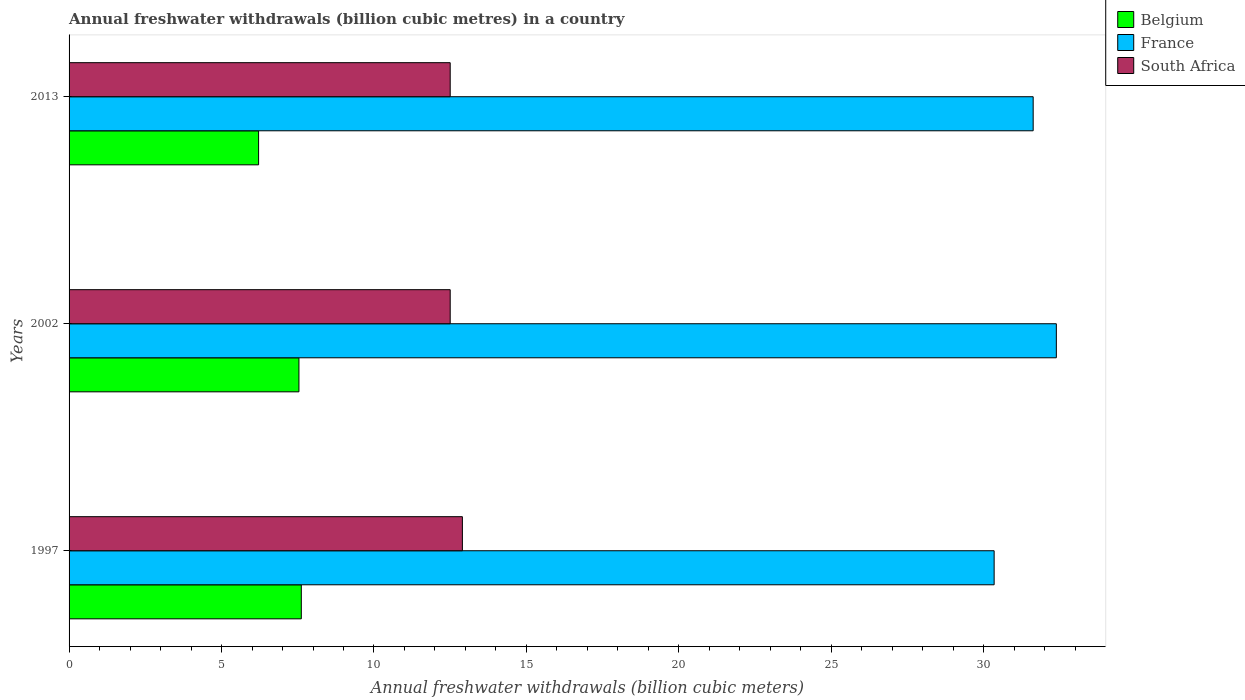How many groups of bars are there?
Provide a succinct answer. 3. Are the number of bars per tick equal to the number of legend labels?
Offer a terse response. Yes. How many bars are there on the 3rd tick from the top?
Offer a very short reply. 3. What is the label of the 1st group of bars from the top?
Provide a succinct answer. 2013. Across all years, what is the maximum annual freshwater withdrawals in France?
Your response must be concise. 32.38. In which year was the annual freshwater withdrawals in South Africa maximum?
Make the answer very short. 1997. In which year was the annual freshwater withdrawals in Belgium minimum?
Make the answer very short. 2013. What is the total annual freshwater withdrawals in France in the graph?
Offer a terse response. 94.34. What is the difference between the annual freshwater withdrawals in South Africa in 1997 and that in 2013?
Offer a terse response. 0.4. What is the difference between the annual freshwater withdrawals in South Africa in 2013 and the annual freshwater withdrawals in Belgium in 1997?
Your answer should be compact. 4.88. What is the average annual freshwater withdrawals in France per year?
Your answer should be very brief. 31.45. In the year 1997, what is the difference between the annual freshwater withdrawals in Belgium and annual freshwater withdrawals in France?
Your answer should be very brief. -22.72. In how many years, is the annual freshwater withdrawals in France greater than 5 billion cubic meters?
Provide a succinct answer. 3. Is the annual freshwater withdrawals in Belgium in 1997 less than that in 2013?
Provide a succinct answer. No. What is the difference between the highest and the second highest annual freshwater withdrawals in South Africa?
Provide a short and direct response. 0.4. What is the difference between the highest and the lowest annual freshwater withdrawals in France?
Give a very brief answer. 2.04. What does the 2nd bar from the bottom in 1997 represents?
Offer a terse response. France. Are the values on the major ticks of X-axis written in scientific E-notation?
Your response must be concise. No. Does the graph contain any zero values?
Make the answer very short. No. Where does the legend appear in the graph?
Your answer should be compact. Top right. How are the legend labels stacked?
Provide a short and direct response. Vertical. What is the title of the graph?
Ensure brevity in your answer.  Annual freshwater withdrawals (billion cubic metres) in a country. Does "St. Kitts and Nevis" appear as one of the legend labels in the graph?
Ensure brevity in your answer.  No. What is the label or title of the X-axis?
Your answer should be compact. Annual freshwater withdrawals (billion cubic meters). What is the Annual freshwater withdrawals (billion cubic meters) in Belgium in 1997?
Provide a succinct answer. 7.62. What is the Annual freshwater withdrawals (billion cubic meters) in France in 1997?
Give a very brief answer. 30.34. What is the Annual freshwater withdrawals (billion cubic meters) in South Africa in 1997?
Make the answer very short. 12.9. What is the Annual freshwater withdrawals (billion cubic meters) in Belgium in 2002?
Your answer should be very brief. 7.54. What is the Annual freshwater withdrawals (billion cubic meters) in France in 2002?
Your response must be concise. 32.38. What is the Annual freshwater withdrawals (billion cubic meters) in Belgium in 2013?
Your answer should be compact. 6.22. What is the Annual freshwater withdrawals (billion cubic meters) in France in 2013?
Give a very brief answer. 31.62. Across all years, what is the maximum Annual freshwater withdrawals (billion cubic meters) of Belgium?
Make the answer very short. 7.62. Across all years, what is the maximum Annual freshwater withdrawals (billion cubic meters) in France?
Offer a terse response. 32.38. Across all years, what is the minimum Annual freshwater withdrawals (billion cubic meters) of Belgium?
Keep it short and to the point. 6.22. Across all years, what is the minimum Annual freshwater withdrawals (billion cubic meters) of France?
Offer a terse response. 30.34. What is the total Annual freshwater withdrawals (billion cubic meters) in Belgium in the graph?
Provide a short and direct response. 21.37. What is the total Annual freshwater withdrawals (billion cubic meters) in France in the graph?
Your answer should be compact. 94.34. What is the total Annual freshwater withdrawals (billion cubic meters) in South Africa in the graph?
Provide a short and direct response. 37.9. What is the difference between the Annual freshwater withdrawals (billion cubic meters) of Belgium in 1997 and that in 2002?
Your answer should be very brief. 0.08. What is the difference between the Annual freshwater withdrawals (billion cubic meters) of France in 1997 and that in 2002?
Your response must be concise. -2.04. What is the difference between the Annual freshwater withdrawals (billion cubic meters) in South Africa in 1997 and that in 2002?
Your answer should be compact. 0.4. What is the difference between the Annual freshwater withdrawals (billion cubic meters) of Belgium in 1997 and that in 2013?
Offer a very short reply. 1.4. What is the difference between the Annual freshwater withdrawals (billion cubic meters) of France in 1997 and that in 2013?
Your answer should be compact. -1.28. What is the difference between the Annual freshwater withdrawals (billion cubic meters) in South Africa in 1997 and that in 2013?
Give a very brief answer. 0.4. What is the difference between the Annual freshwater withdrawals (billion cubic meters) in Belgium in 2002 and that in 2013?
Your answer should be very brief. 1.32. What is the difference between the Annual freshwater withdrawals (billion cubic meters) of France in 2002 and that in 2013?
Ensure brevity in your answer.  0.76. What is the difference between the Annual freshwater withdrawals (billion cubic meters) of Belgium in 1997 and the Annual freshwater withdrawals (billion cubic meters) of France in 2002?
Your answer should be very brief. -24.76. What is the difference between the Annual freshwater withdrawals (billion cubic meters) in Belgium in 1997 and the Annual freshwater withdrawals (billion cubic meters) in South Africa in 2002?
Make the answer very short. -4.88. What is the difference between the Annual freshwater withdrawals (billion cubic meters) in France in 1997 and the Annual freshwater withdrawals (billion cubic meters) in South Africa in 2002?
Provide a succinct answer. 17.84. What is the difference between the Annual freshwater withdrawals (billion cubic meters) of Belgium in 1997 and the Annual freshwater withdrawals (billion cubic meters) of France in 2013?
Your answer should be compact. -24. What is the difference between the Annual freshwater withdrawals (billion cubic meters) of Belgium in 1997 and the Annual freshwater withdrawals (billion cubic meters) of South Africa in 2013?
Ensure brevity in your answer.  -4.88. What is the difference between the Annual freshwater withdrawals (billion cubic meters) in France in 1997 and the Annual freshwater withdrawals (billion cubic meters) in South Africa in 2013?
Your answer should be very brief. 17.84. What is the difference between the Annual freshwater withdrawals (billion cubic meters) of Belgium in 2002 and the Annual freshwater withdrawals (billion cubic meters) of France in 2013?
Make the answer very short. -24.08. What is the difference between the Annual freshwater withdrawals (billion cubic meters) of Belgium in 2002 and the Annual freshwater withdrawals (billion cubic meters) of South Africa in 2013?
Offer a very short reply. -4.96. What is the difference between the Annual freshwater withdrawals (billion cubic meters) in France in 2002 and the Annual freshwater withdrawals (billion cubic meters) in South Africa in 2013?
Give a very brief answer. 19.88. What is the average Annual freshwater withdrawals (billion cubic meters) of Belgium per year?
Keep it short and to the point. 7.12. What is the average Annual freshwater withdrawals (billion cubic meters) in France per year?
Your response must be concise. 31.45. What is the average Annual freshwater withdrawals (billion cubic meters) of South Africa per year?
Offer a very short reply. 12.63. In the year 1997, what is the difference between the Annual freshwater withdrawals (billion cubic meters) in Belgium and Annual freshwater withdrawals (billion cubic meters) in France?
Ensure brevity in your answer.  -22.72. In the year 1997, what is the difference between the Annual freshwater withdrawals (billion cubic meters) of Belgium and Annual freshwater withdrawals (billion cubic meters) of South Africa?
Your answer should be very brief. -5.28. In the year 1997, what is the difference between the Annual freshwater withdrawals (billion cubic meters) of France and Annual freshwater withdrawals (billion cubic meters) of South Africa?
Ensure brevity in your answer.  17.44. In the year 2002, what is the difference between the Annual freshwater withdrawals (billion cubic meters) of Belgium and Annual freshwater withdrawals (billion cubic meters) of France?
Provide a succinct answer. -24.84. In the year 2002, what is the difference between the Annual freshwater withdrawals (billion cubic meters) in Belgium and Annual freshwater withdrawals (billion cubic meters) in South Africa?
Make the answer very short. -4.96. In the year 2002, what is the difference between the Annual freshwater withdrawals (billion cubic meters) of France and Annual freshwater withdrawals (billion cubic meters) of South Africa?
Offer a very short reply. 19.88. In the year 2013, what is the difference between the Annual freshwater withdrawals (billion cubic meters) in Belgium and Annual freshwater withdrawals (billion cubic meters) in France?
Make the answer very short. -25.4. In the year 2013, what is the difference between the Annual freshwater withdrawals (billion cubic meters) of Belgium and Annual freshwater withdrawals (billion cubic meters) of South Africa?
Ensure brevity in your answer.  -6.28. In the year 2013, what is the difference between the Annual freshwater withdrawals (billion cubic meters) of France and Annual freshwater withdrawals (billion cubic meters) of South Africa?
Give a very brief answer. 19.12. What is the ratio of the Annual freshwater withdrawals (billion cubic meters) of Belgium in 1997 to that in 2002?
Give a very brief answer. 1.01. What is the ratio of the Annual freshwater withdrawals (billion cubic meters) in France in 1997 to that in 2002?
Offer a very short reply. 0.94. What is the ratio of the Annual freshwater withdrawals (billion cubic meters) of South Africa in 1997 to that in 2002?
Offer a very short reply. 1.03. What is the ratio of the Annual freshwater withdrawals (billion cubic meters) in Belgium in 1997 to that in 2013?
Your answer should be compact. 1.23. What is the ratio of the Annual freshwater withdrawals (billion cubic meters) in France in 1997 to that in 2013?
Make the answer very short. 0.96. What is the ratio of the Annual freshwater withdrawals (billion cubic meters) in South Africa in 1997 to that in 2013?
Keep it short and to the point. 1.03. What is the ratio of the Annual freshwater withdrawals (billion cubic meters) of Belgium in 2002 to that in 2013?
Your answer should be compact. 1.21. What is the difference between the highest and the second highest Annual freshwater withdrawals (billion cubic meters) in Belgium?
Keep it short and to the point. 0.08. What is the difference between the highest and the second highest Annual freshwater withdrawals (billion cubic meters) of France?
Your answer should be very brief. 0.76. What is the difference between the highest and the second highest Annual freshwater withdrawals (billion cubic meters) of South Africa?
Your answer should be compact. 0.4. What is the difference between the highest and the lowest Annual freshwater withdrawals (billion cubic meters) in Belgium?
Keep it short and to the point. 1.4. What is the difference between the highest and the lowest Annual freshwater withdrawals (billion cubic meters) of France?
Keep it short and to the point. 2.04. What is the difference between the highest and the lowest Annual freshwater withdrawals (billion cubic meters) in South Africa?
Your answer should be very brief. 0.4. 